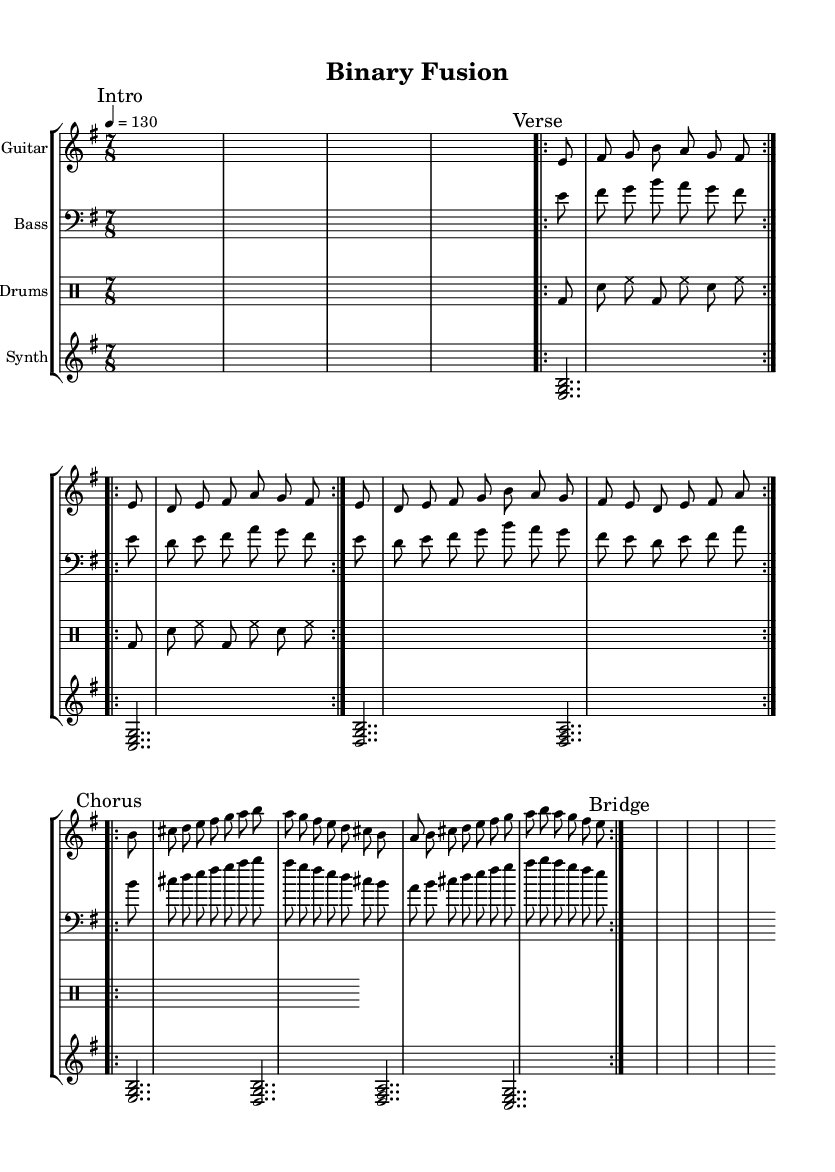What is the key signature of this music? The key signature is E minor, which corresponds to one sharp (F#) on the staff. This can be determined by looking for the sharp sign(s) in the key signature area.
Answer: E minor What is the time signature of the music? The time signature shown is 7/8, which indicates seven beats per measure with each beat being an eighth note. This can be deduced from the ‘\time 7/8’ notation at the beginning of the score.
Answer: 7/8 What is the tempo marking for this piece? The tempo marking is 130, indicated as ‘\tempo 4 = 130’, which suggests the piece should be played at 130 beats per minute. The '4' represents the quarter note, which is commonly used for tempo indications.
Answer: 130 How many times is the verse repeated? The verse is marked to be repeated twice, as indicated by ‘\repeat volta 2 { \verse }’. This shows that the musical section defined as the verse should be played two times in total.
Answer: 2 What instruments are used in this arrangement? The instruments indicated in the score are Guitar, Bass, Drums, and Synth, referenced in the staff groupings at the beginning of each section. Each instrument is indicated with a specified instrument name.
Answer: Guitar, Bass, Drums, Synth How many measures are in the chorus section? The chorus section consists of four measures, since in the repeated section 'repeat volta 2 { \chorus }', each instance has four measures as defined in the chorus musical lines.
Answer: 4 What type of vocals are implied in this music? The music incorporates robotic vocals, as the question specifically notes the stylistic choice of robotic elements, consistent with avant-garde metal's thematic exploration of human-machine hybrids. This is inferred from the genre description provided.
Answer: Robotic 